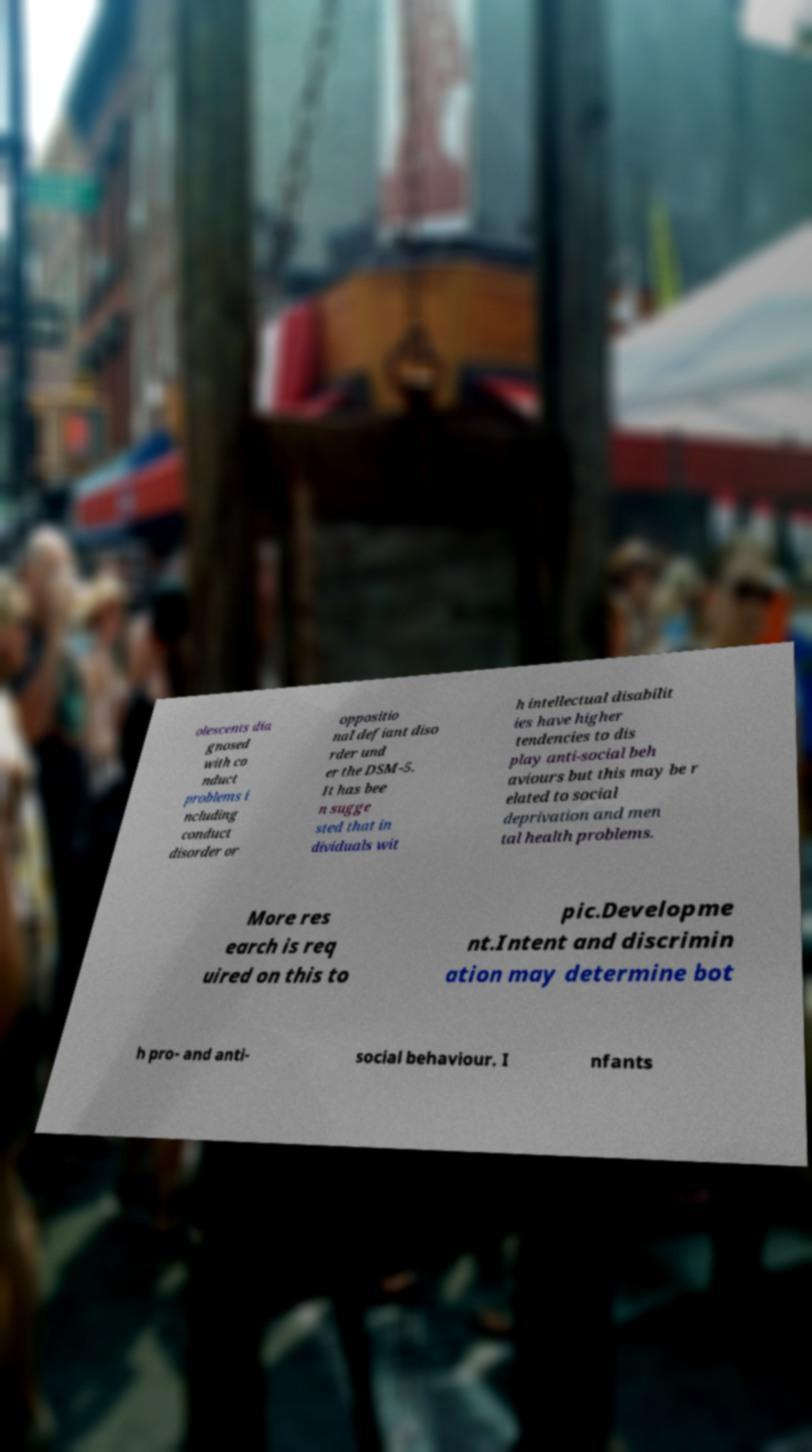What messages or text are displayed in this image? I need them in a readable, typed format. olescents dia gnosed with co nduct problems i ncluding conduct disorder or oppositio nal defiant diso rder und er the DSM-5. It has bee n sugge sted that in dividuals wit h intellectual disabilit ies have higher tendencies to dis play anti-social beh aviours but this may be r elated to social deprivation and men tal health problems. More res earch is req uired on this to pic.Developme nt.Intent and discrimin ation may determine bot h pro- and anti- social behaviour. I nfants 